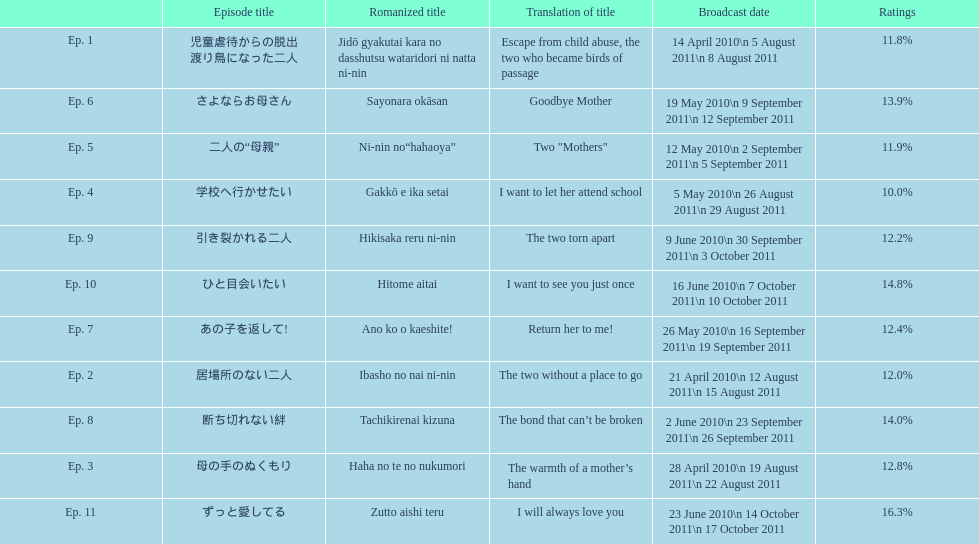What as the percentage total of ratings for episode 8? 14.0%. 